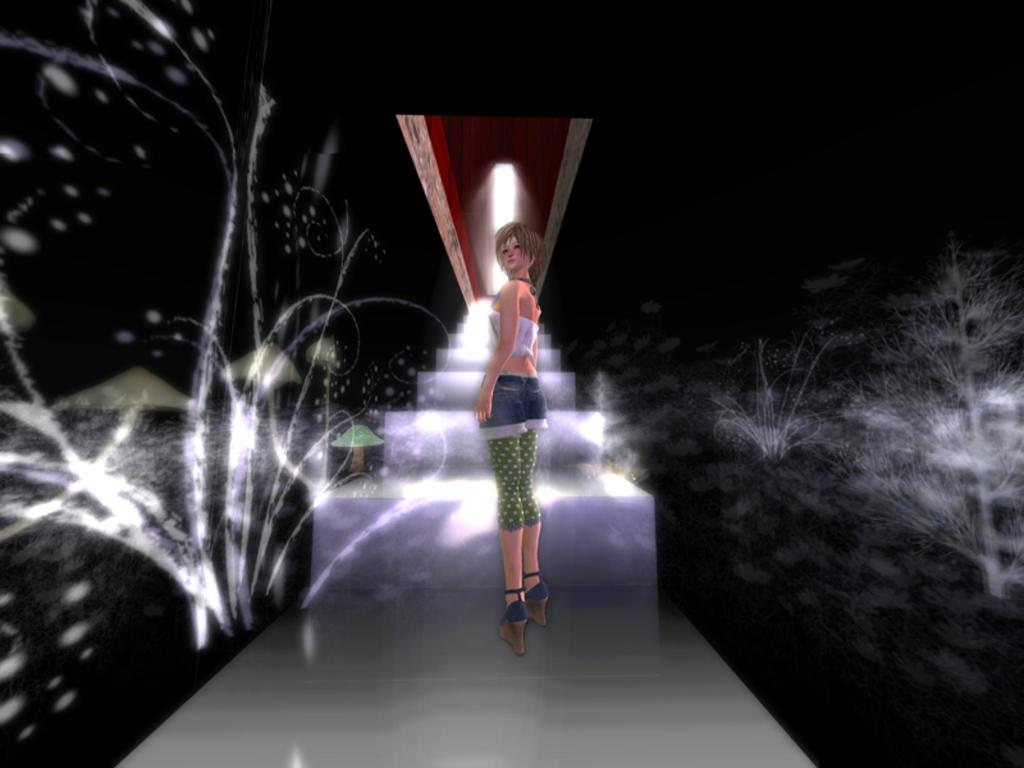What is the main subject of the image? There is a person standing in the center of the image. What can be seen in the background of the image? There are lights and objects visible in the background of the image. What type of doll is sitting in the church in the image? There is no doll or church present in the image; it features a person standing in the center and objects in the background. 